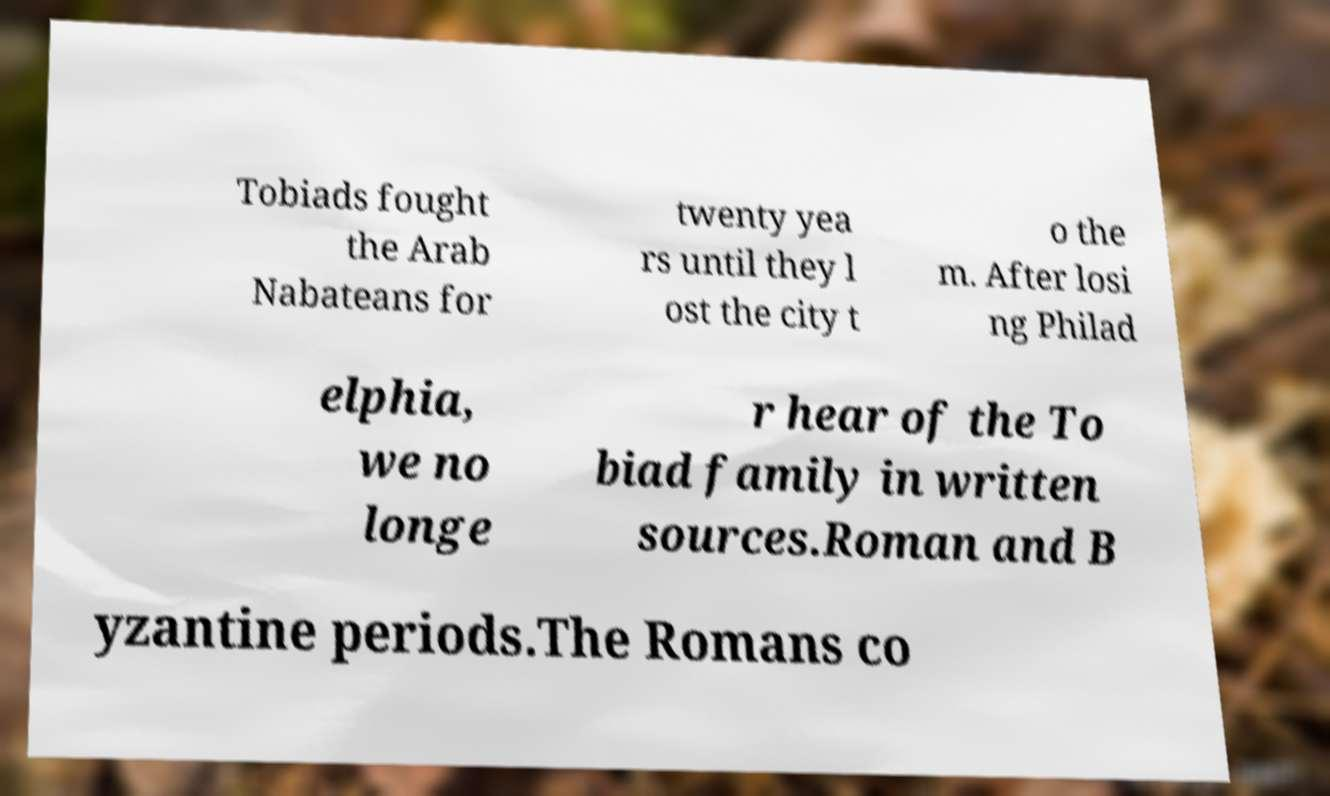Could you assist in decoding the text presented in this image and type it out clearly? Tobiads fought the Arab Nabateans for twenty yea rs until they l ost the city t o the m. After losi ng Philad elphia, we no longe r hear of the To biad family in written sources.Roman and B yzantine periods.The Romans co 